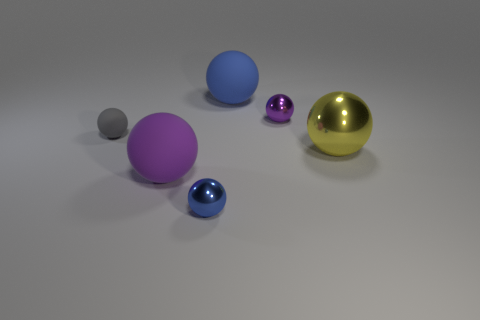What time of day does the lighting in the scene suggest? The lighting in the scene does not strongly suggest any particular time of day given the indoor setting and controlled light sources, which are designed to evenly illuminate the objects without hints of natural sunlight or shadows that would indicate a time of day. 